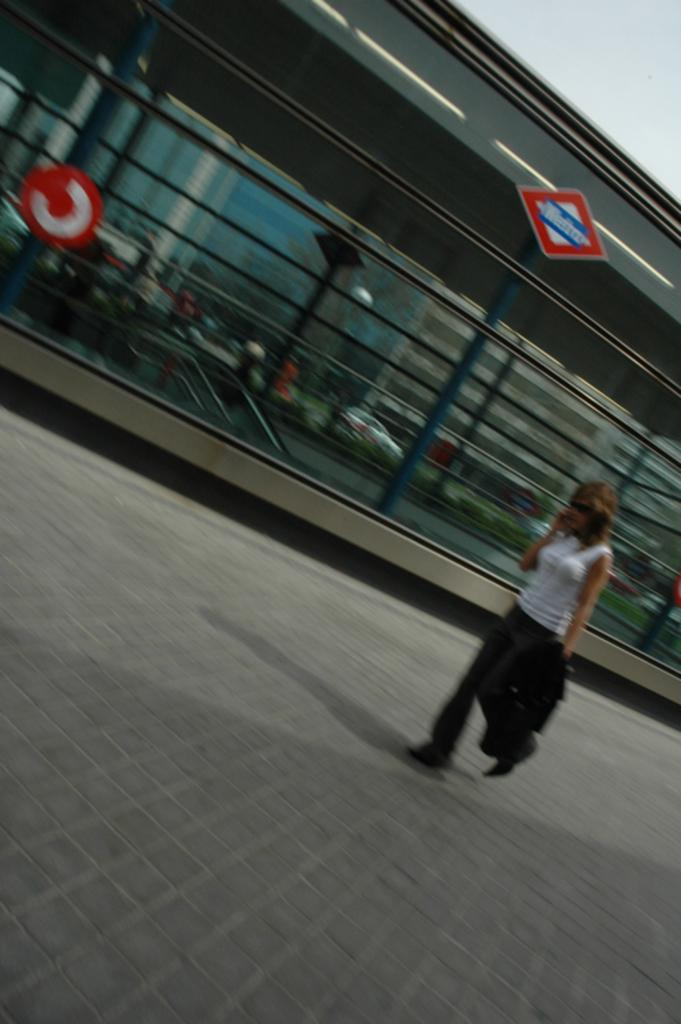Who is the main subject in the foreground of the image? There is a woman in the foreground of the image. What is the woman doing in the image? The woman is walking on the ground. What can be seen in the background of the image? There is a metro station and a building in the background of the image, as well as the sky. How does the woman react to the sudden impulse in the image? There is no mention of an impulse or any reaction to it in the image. 